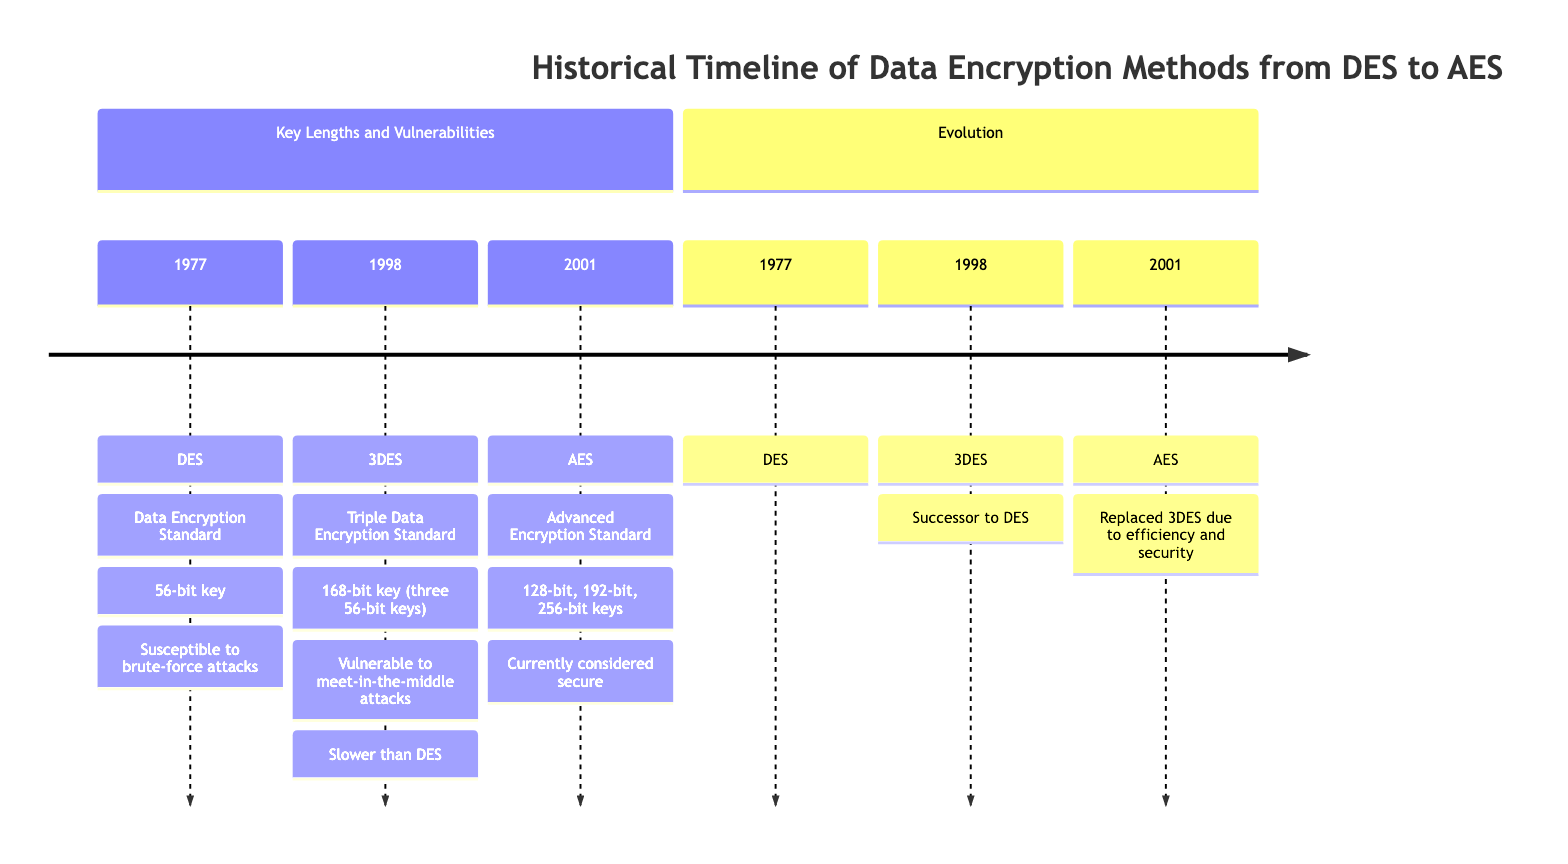What year was DES introduced? The diagram clearly states that DES was introduced in 1977. This information can be directly found within the first section of the timeline under the entry for DES.
Answer: 1977 What is the key length of AES? In the section that describes AES, it mentions that AES supports multiple key lengths: 128-bit, 192-bit, and 256-bit. This is explicitly written in the provided details of the diagram.
Answer: 128-bit, 192-bit, 256-bit Which encryption method succeeded DES? According to the evolution section, 3DES is noted as the successor to DES, indicating a direct relationship where 3DES followed DES in the timeline of encryption methods.
Answer: 3DES What attack is DES vulnerable to? The vulnerabilities section for DES specifies that it is susceptible to brute-force attacks. This directly answers the question as the information is clearly stated in the diagram under DES.
Answer: Brute-force Which encryption method is currently considered secure? Looking at the section detailing AES, it concludes that AES is currently considered secure, a statement made right after mentioning its key lengths. This indicates its reliability in modern encryption standards.
Answer: AES What is the total number of encryption methods depicted in the timeline? The diagram illustrates three encryption methods: DES, 3DES, and AES. By counting each of these distinct entries, we arrive at the total number of methods shown on the timeline.
Answer: 3 What is the key length of 3DES? The diagram specifies that 3DES employs a key length of 168 bits, achieved by using three 56-bit keys. This detail can be found in the description under the 3DES entry.
Answer: 168-bit In what year was 3DES introduced? From the timeline, it is indicated that 3DES was introduced in 1998, providing a clear year associated with its introduction. This can be directly referenced from the timeline section for 3DES.
Answer: 1998 What are the vulnerabilities of 3DES? The vulnerabilities section for 3DES states it is vulnerable to meet-in-the-middle attacks and is also slower than DES. Both of these pieces of information are noted together, allowing for a comprehensive answer regarding its vulnerabilities.
Answer: Meet-in-the-middle attacks, slower than DES 